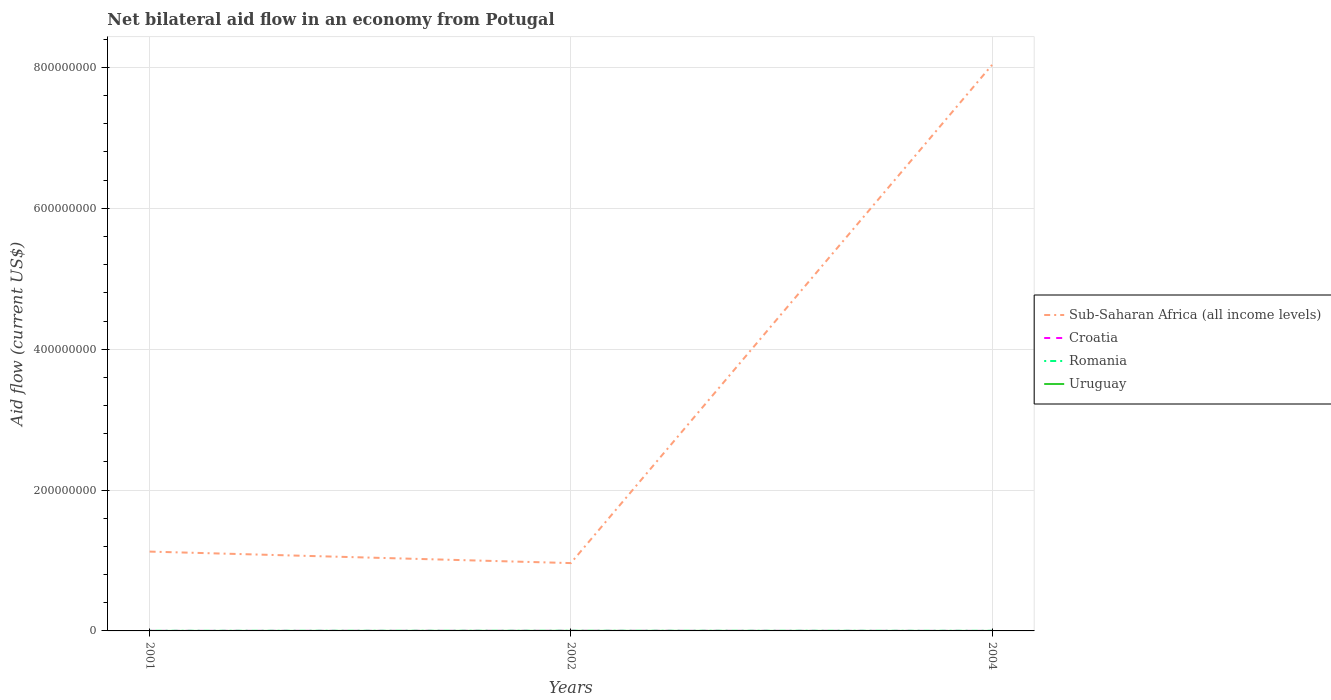Across all years, what is the maximum net bilateral aid flow in Croatia?
Your answer should be compact. 10000. What is the total net bilateral aid flow in Romania in the graph?
Your response must be concise. 2.00e+04. What is the difference between the highest and the second highest net bilateral aid flow in Uruguay?
Keep it short and to the point. 7.00e+04. What is the difference between the highest and the lowest net bilateral aid flow in Sub-Saharan Africa (all income levels)?
Make the answer very short. 1. Is the net bilateral aid flow in Sub-Saharan Africa (all income levels) strictly greater than the net bilateral aid flow in Romania over the years?
Make the answer very short. No. How many lines are there?
Provide a succinct answer. 4. What is the difference between two consecutive major ticks on the Y-axis?
Ensure brevity in your answer.  2.00e+08. Are the values on the major ticks of Y-axis written in scientific E-notation?
Offer a very short reply. No. Does the graph contain any zero values?
Your response must be concise. No. Does the graph contain grids?
Provide a succinct answer. Yes. How are the legend labels stacked?
Give a very brief answer. Vertical. What is the title of the graph?
Your answer should be very brief. Net bilateral aid flow in an economy from Potugal. What is the label or title of the Y-axis?
Your response must be concise. Aid flow (current US$). What is the Aid flow (current US$) of Sub-Saharan Africa (all income levels) in 2001?
Make the answer very short. 1.13e+08. What is the Aid flow (current US$) of Romania in 2001?
Your response must be concise. 1.20e+05. What is the Aid flow (current US$) of Sub-Saharan Africa (all income levels) in 2002?
Give a very brief answer. 9.63e+07. What is the Aid flow (current US$) of Croatia in 2002?
Offer a very short reply. 1.00e+05. What is the Aid flow (current US$) in Sub-Saharan Africa (all income levels) in 2004?
Provide a short and direct response. 8.04e+08. What is the Aid flow (current US$) of Croatia in 2004?
Ensure brevity in your answer.  10000. What is the Aid flow (current US$) of Romania in 2004?
Provide a succinct answer. 1.00e+05. Across all years, what is the maximum Aid flow (current US$) of Sub-Saharan Africa (all income levels)?
Keep it short and to the point. 8.04e+08. Across all years, what is the maximum Aid flow (current US$) in Romania?
Your response must be concise. 1.20e+05. Across all years, what is the minimum Aid flow (current US$) in Sub-Saharan Africa (all income levels)?
Provide a succinct answer. 9.63e+07. Across all years, what is the minimum Aid flow (current US$) in Croatia?
Keep it short and to the point. 10000. Across all years, what is the minimum Aid flow (current US$) of Uruguay?
Provide a short and direct response. 10000. What is the total Aid flow (current US$) in Sub-Saharan Africa (all income levels) in the graph?
Your answer should be very brief. 1.01e+09. What is the total Aid flow (current US$) of Romania in the graph?
Provide a succinct answer. 3.20e+05. What is the total Aid flow (current US$) in Uruguay in the graph?
Make the answer very short. 1.00e+05. What is the difference between the Aid flow (current US$) of Sub-Saharan Africa (all income levels) in 2001 and that in 2002?
Offer a terse response. 1.63e+07. What is the difference between the Aid flow (current US$) of Sub-Saharan Africa (all income levels) in 2001 and that in 2004?
Give a very brief answer. -6.91e+08. What is the difference between the Aid flow (current US$) of Croatia in 2001 and that in 2004?
Keep it short and to the point. 3.00e+04. What is the difference between the Aid flow (current US$) of Romania in 2001 and that in 2004?
Offer a very short reply. 2.00e+04. What is the difference between the Aid flow (current US$) in Uruguay in 2001 and that in 2004?
Offer a very short reply. 0. What is the difference between the Aid flow (current US$) of Sub-Saharan Africa (all income levels) in 2002 and that in 2004?
Offer a terse response. -7.07e+08. What is the difference between the Aid flow (current US$) in Sub-Saharan Africa (all income levels) in 2001 and the Aid flow (current US$) in Croatia in 2002?
Provide a short and direct response. 1.13e+08. What is the difference between the Aid flow (current US$) in Sub-Saharan Africa (all income levels) in 2001 and the Aid flow (current US$) in Romania in 2002?
Your response must be concise. 1.13e+08. What is the difference between the Aid flow (current US$) of Sub-Saharan Africa (all income levels) in 2001 and the Aid flow (current US$) of Uruguay in 2002?
Give a very brief answer. 1.13e+08. What is the difference between the Aid flow (current US$) in Croatia in 2001 and the Aid flow (current US$) in Romania in 2002?
Ensure brevity in your answer.  -6.00e+04. What is the difference between the Aid flow (current US$) of Croatia in 2001 and the Aid flow (current US$) of Uruguay in 2002?
Give a very brief answer. -4.00e+04. What is the difference between the Aid flow (current US$) in Romania in 2001 and the Aid flow (current US$) in Uruguay in 2002?
Provide a short and direct response. 4.00e+04. What is the difference between the Aid flow (current US$) of Sub-Saharan Africa (all income levels) in 2001 and the Aid flow (current US$) of Croatia in 2004?
Your answer should be compact. 1.13e+08. What is the difference between the Aid flow (current US$) of Sub-Saharan Africa (all income levels) in 2001 and the Aid flow (current US$) of Romania in 2004?
Make the answer very short. 1.13e+08. What is the difference between the Aid flow (current US$) of Sub-Saharan Africa (all income levels) in 2001 and the Aid flow (current US$) of Uruguay in 2004?
Give a very brief answer. 1.13e+08. What is the difference between the Aid flow (current US$) of Croatia in 2001 and the Aid flow (current US$) of Romania in 2004?
Make the answer very short. -6.00e+04. What is the difference between the Aid flow (current US$) of Sub-Saharan Africa (all income levels) in 2002 and the Aid flow (current US$) of Croatia in 2004?
Ensure brevity in your answer.  9.63e+07. What is the difference between the Aid flow (current US$) in Sub-Saharan Africa (all income levels) in 2002 and the Aid flow (current US$) in Romania in 2004?
Give a very brief answer. 9.62e+07. What is the difference between the Aid flow (current US$) in Sub-Saharan Africa (all income levels) in 2002 and the Aid flow (current US$) in Uruguay in 2004?
Your response must be concise. 9.63e+07. What is the average Aid flow (current US$) of Sub-Saharan Africa (all income levels) per year?
Ensure brevity in your answer.  3.38e+08. What is the average Aid flow (current US$) of Croatia per year?
Your response must be concise. 5.00e+04. What is the average Aid flow (current US$) in Romania per year?
Keep it short and to the point. 1.07e+05. What is the average Aid flow (current US$) in Uruguay per year?
Keep it short and to the point. 3.33e+04. In the year 2001, what is the difference between the Aid flow (current US$) in Sub-Saharan Africa (all income levels) and Aid flow (current US$) in Croatia?
Your answer should be compact. 1.13e+08. In the year 2001, what is the difference between the Aid flow (current US$) in Sub-Saharan Africa (all income levels) and Aid flow (current US$) in Romania?
Your answer should be compact. 1.12e+08. In the year 2001, what is the difference between the Aid flow (current US$) in Sub-Saharan Africa (all income levels) and Aid flow (current US$) in Uruguay?
Keep it short and to the point. 1.13e+08. In the year 2001, what is the difference between the Aid flow (current US$) of Croatia and Aid flow (current US$) of Uruguay?
Offer a terse response. 3.00e+04. In the year 2001, what is the difference between the Aid flow (current US$) in Romania and Aid flow (current US$) in Uruguay?
Give a very brief answer. 1.10e+05. In the year 2002, what is the difference between the Aid flow (current US$) of Sub-Saharan Africa (all income levels) and Aid flow (current US$) of Croatia?
Give a very brief answer. 9.62e+07. In the year 2002, what is the difference between the Aid flow (current US$) in Sub-Saharan Africa (all income levels) and Aid flow (current US$) in Romania?
Give a very brief answer. 9.62e+07. In the year 2002, what is the difference between the Aid flow (current US$) in Sub-Saharan Africa (all income levels) and Aid flow (current US$) in Uruguay?
Your answer should be very brief. 9.62e+07. In the year 2002, what is the difference between the Aid flow (current US$) in Romania and Aid flow (current US$) in Uruguay?
Provide a short and direct response. 2.00e+04. In the year 2004, what is the difference between the Aid flow (current US$) in Sub-Saharan Africa (all income levels) and Aid flow (current US$) in Croatia?
Offer a terse response. 8.04e+08. In the year 2004, what is the difference between the Aid flow (current US$) of Sub-Saharan Africa (all income levels) and Aid flow (current US$) of Romania?
Keep it short and to the point. 8.04e+08. In the year 2004, what is the difference between the Aid flow (current US$) in Sub-Saharan Africa (all income levels) and Aid flow (current US$) in Uruguay?
Provide a short and direct response. 8.04e+08. In the year 2004, what is the difference between the Aid flow (current US$) in Croatia and Aid flow (current US$) in Romania?
Offer a very short reply. -9.00e+04. In the year 2004, what is the difference between the Aid flow (current US$) of Romania and Aid flow (current US$) of Uruguay?
Offer a terse response. 9.00e+04. What is the ratio of the Aid flow (current US$) in Sub-Saharan Africa (all income levels) in 2001 to that in 2002?
Make the answer very short. 1.17. What is the ratio of the Aid flow (current US$) in Sub-Saharan Africa (all income levels) in 2001 to that in 2004?
Keep it short and to the point. 0.14. What is the ratio of the Aid flow (current US$) in Croatia in 2001 to that in 2004?
Keep it short and to the point. 4. What is the ratio of the Aid flow (current US$) in Romania in 2001 to that in 2004?
Your answer should be very brief. 1.2. What is the ratio of the Aid flow (current US$) in Uruguay in 2001 to that in 2004?
Provide a succinct answer. 1. What is the ratio of the Aid flow (current US$) in Sub-Saharan Africa (all income levels) in 2002 to that in 2004?
Your answer should be compact. 0.12. What is the ratio of the Aid flow (current US$) in Uruguay in 2002 to that in 2004?
Give a very brief answer. 8. What is the difference between the highest and the second highest Aid flow (current US$) of Sub-Saharan Africa (all income levels)?
Your answer should be compact. 6.91e+08. What is the difference between the highest and the second highest Aid flow (current US$) of Croatia?
Ensure brevity in your answer.  6.00e+04. What is the difference between the highest and the second highest Aid flow (current US$) in Uruguay?
Make the answer very short. 7.00e+04. What is the difference between the highest and the lowest Aid flow (current US$) in Sub-Saharan Africa (all income levels)?
Keep it short and to the point. 7.07e+08. What is the difference between the highest and the lowest Aid flow (current US$) in Croatia?
Provide a succinct answer. 9.00e+04. 